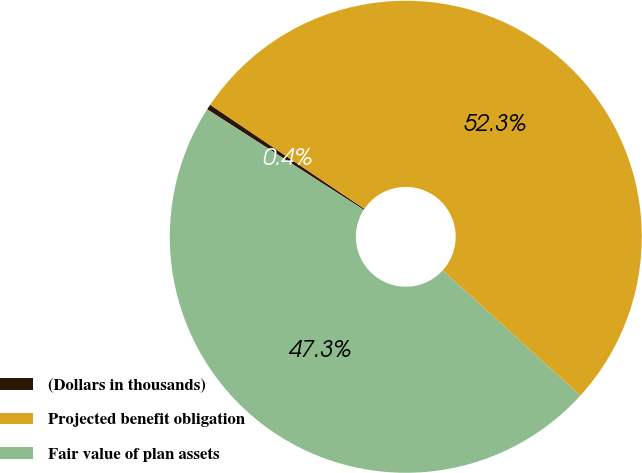Convert chart to OTSL. <chart><loc_0><loc_0><loc_500><loc_500><pie_chart><fcel>(Dollars in thousands)<fcel>Projected benefit obligation<fcel>Fair value of plan assets<nl><fcel>0.37%<fcel>52.3%<fcel>47.33%<nl></chart> 